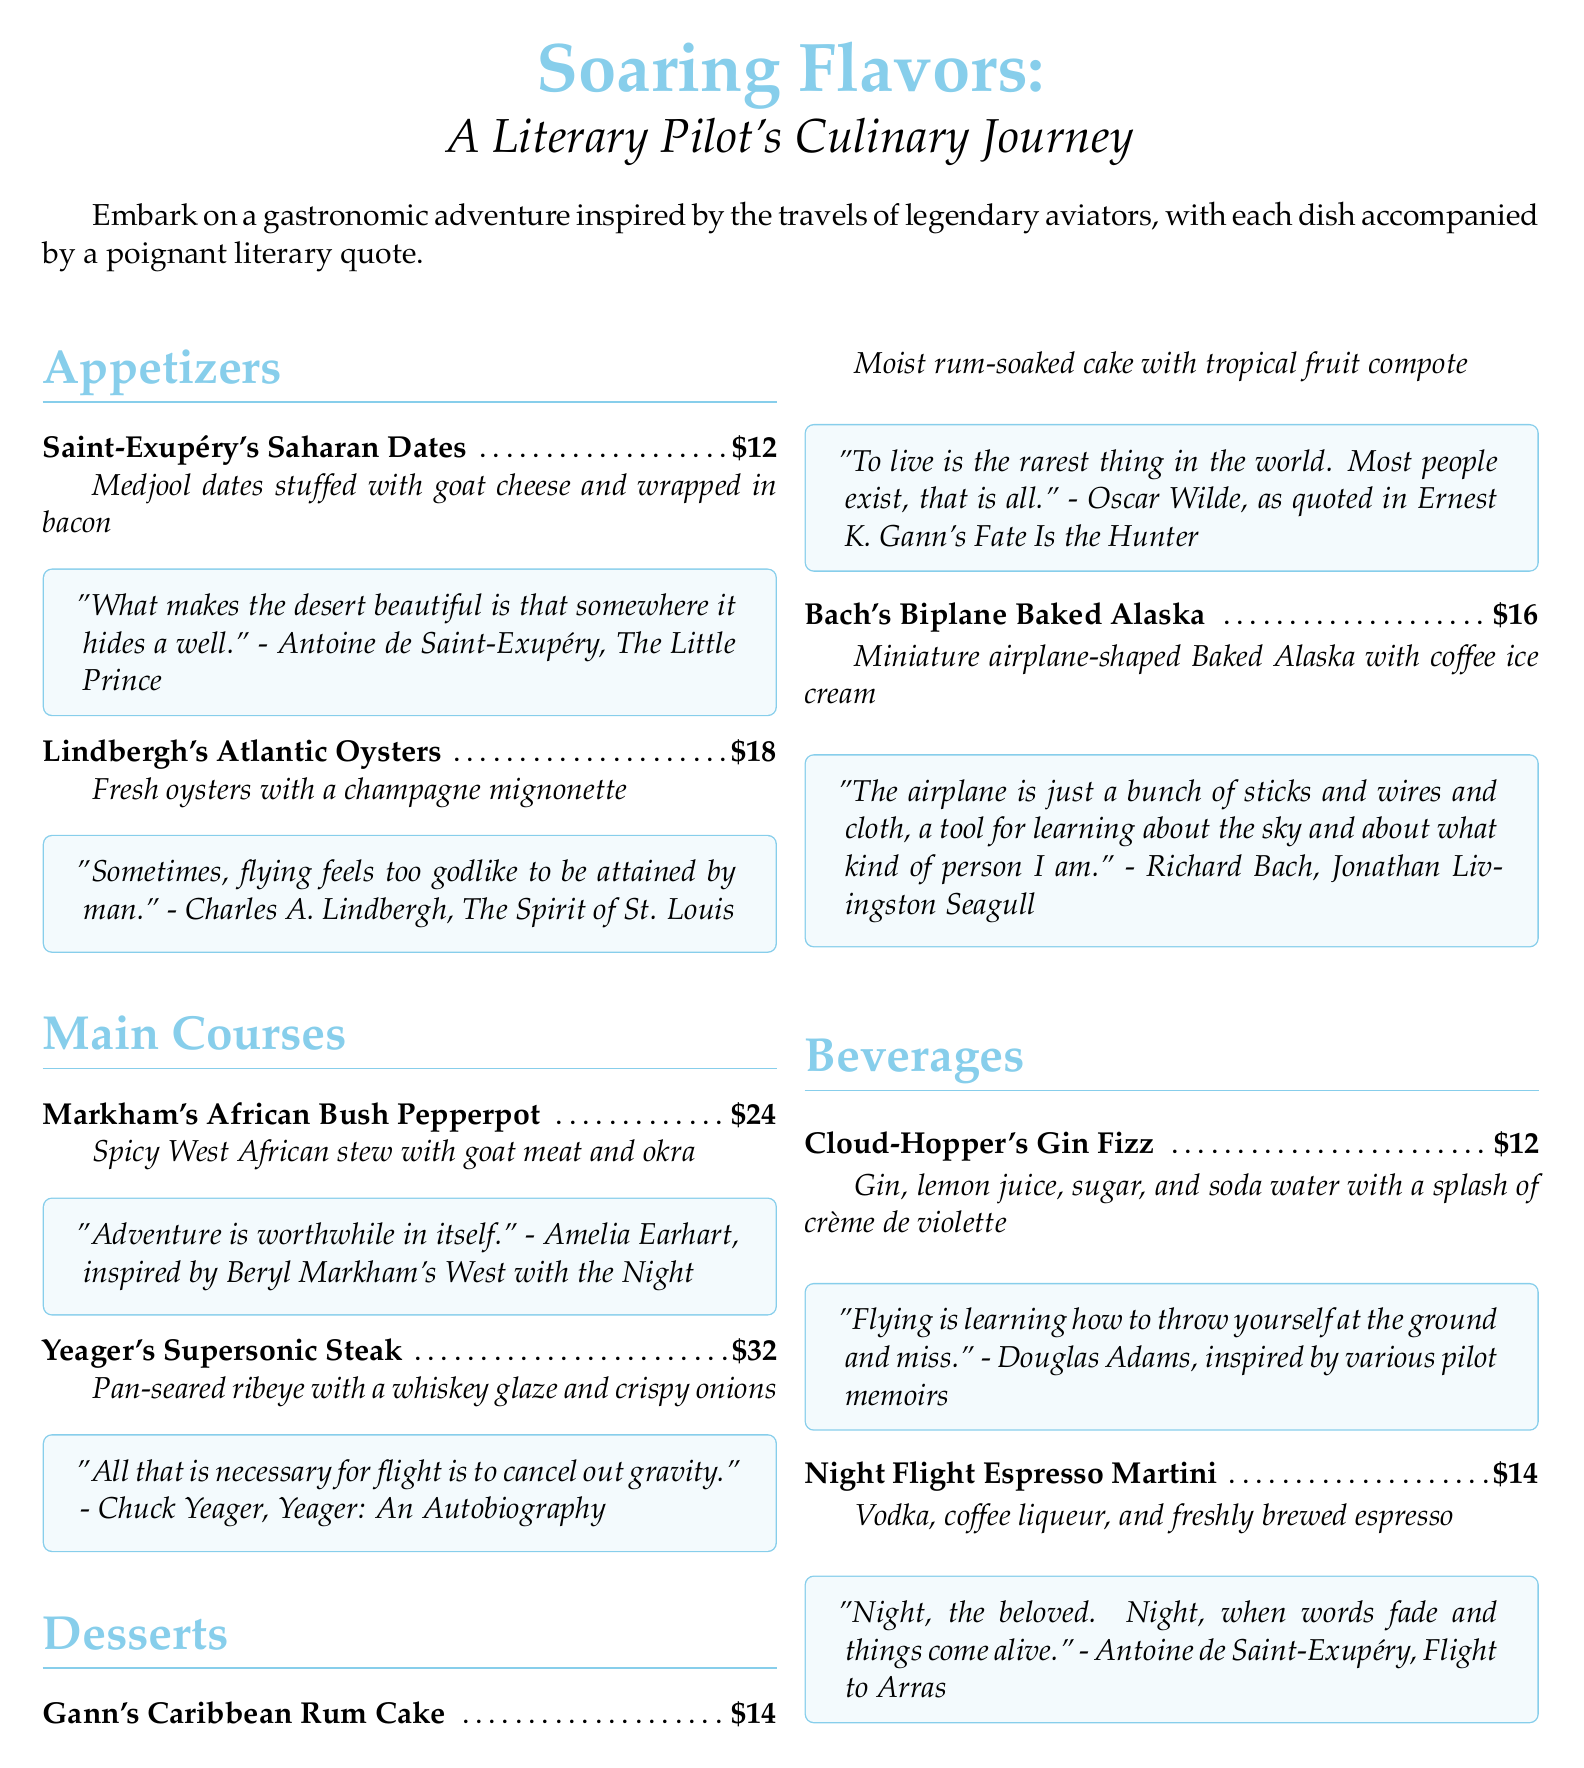What is the price of Saint-Exupéry's Saharan Dates? The price of each item is listed next to its name in the menu. Saint-Exupéry's Saharan Dates are priced at $12.
Answer: $12 Which author inspired the African Bush Pepperpot dish? The menu quotes Amelia Earhart and mentions Beryl Markham as the inspiration for the African Bush Pepperpot dish.
Answer: Beryl Markham What are the main ingredients in Gann's Caribbean Rum Cake? The description of Gann's Caribbean Rum Cake lists it as a rum-soaked cake with tropical fruit compote, highlighting the main components.
Answer: Rum-soaked cake with tropical fruit compote What is the name of the beverage that includes crème de violette? The beverage list specifies a drink that includes crème de violette, which is Cloud-Hopper's Gin Fizz.
Answer: Cloud-Hopper's Gin Fizz What literary quote accompanies Yeager's Supersonic Steak? Each dish is paired with a quote, and for Yeager's Supersonic Steak, the quote discusses gravity and flight.
Answer: "All that is necessary for flight is to cancel out gravity." What type of dessert is shaped like an airplane? The menu describes a dessert that is miniature airplane-shaped, which is Baked Alaska.
Answer: Baked Alaska 